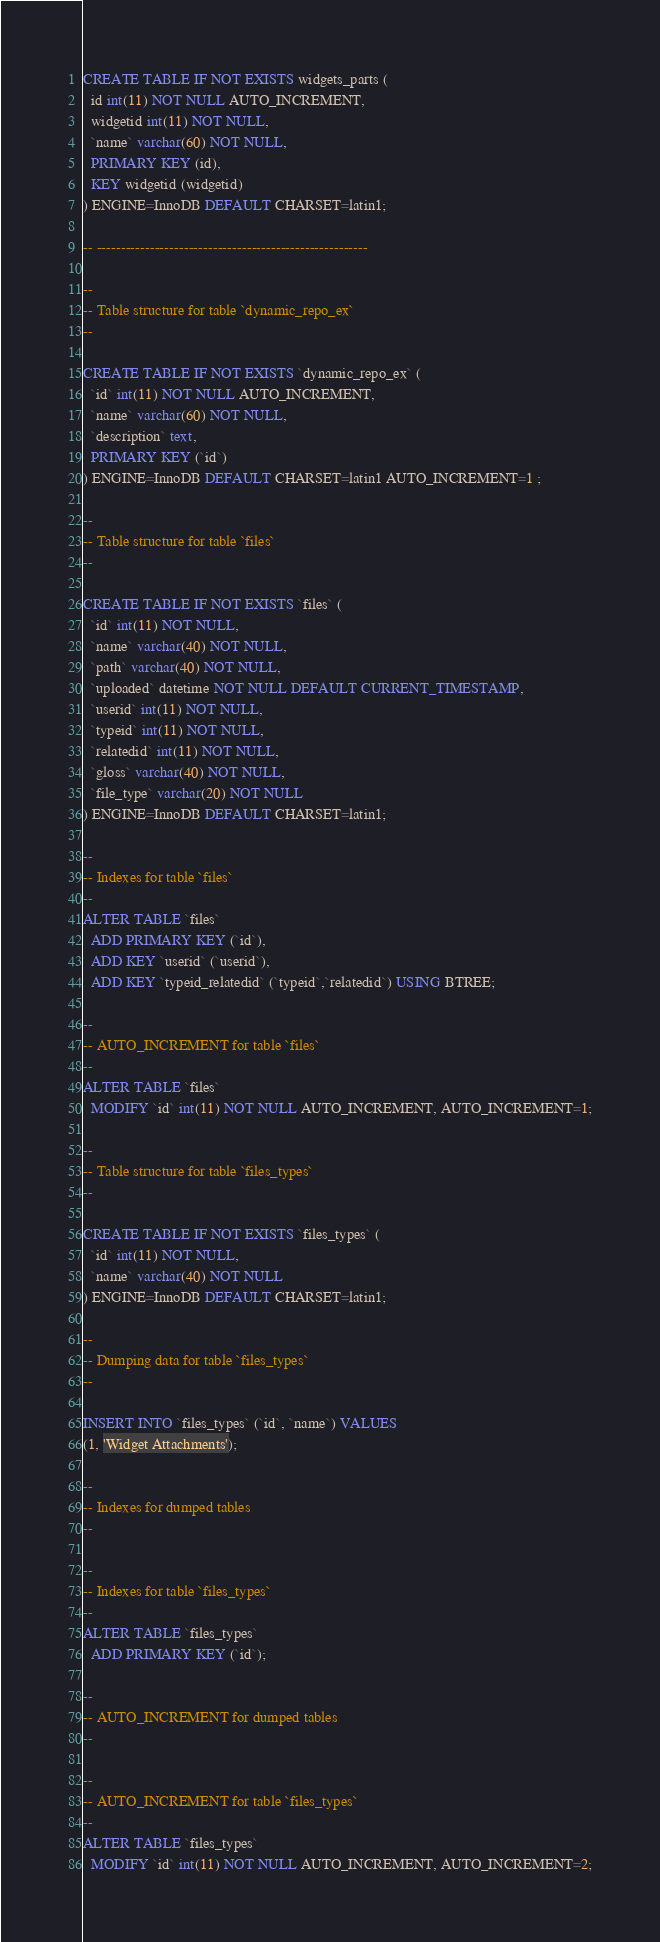Convert code to text. <code><loc_0><loc_0><loc_500><loc_500><_SQL_>
CREATE TABLE IF NOT EXISTS widgets_parts (
  id int(11) NOT NULL AUTO_INCREMENT,
  widgetid int(11) NOT NULL,
  `name` varchar(60) NOT NULL,
  PRIMARY KEY (id),
  KEY widgetid (widgetid)
) ENGINE=InnoDB DEFAULT CHARSET=latin1;

-- --------------------------------------------------------

--
-- Table structure for table `dynamic_repo_ex`
--

CREATE TABLE IF NOT EXISTS `dynamic_repo_ex` (
  `id` int(11) NOT NULL AUTO_INCREMENT,
  `name` varchar(60) NOT NULL,
  `description` text,
  PRIMARY KEY (`id`)
) ENGINE=InnoDB DEFAULT CHARSET=latin1 AUTO_INCREMENT=1 ;

--
-- Table structure for table `files`
--

CREATE TABLE IF NOT EXISTS `files` (
  `id` int(11) NOT NULL,
  `name` varchar(40) NOT NULL,
  `path` varchar(40) NOT NULL,
  `uploaded` datetime NOT NULL DEFAULT CURRENT_TIMESTAMP,
  `userid` int(11) NOT NULL,
  `typeid` int(11) NOT NULL,
  `relatedid` int(11) NOT NULL,
  `gloss` varchar(40) NOT NULL,
  `file_type` varchar(20) NOT NULL
) ENGINE=InnoDB DEFAULT CHARSET=latin1;

--
-- Indexes for table `files`
--
ALTER TABLE `files`
  ADD PRIMARY KEY (`id`),
  ADD KEY `userid` (`userid`),
  ADD KEY `typeid_relatedid` (`typeid`,`relatedid`) USING BTREE;

--
-- AUTO_INCREMENT for table `files`
--
ALTER TABLE `files`
  MODIFY `id` int(11) NOT NULL AUTO_INCREMENT, AUTO_INCREMENT=1;

--
-- Table structure for table `files_types`
--

CREATE TABLE IF NOT EXISTS `files_types` (
  `id` int(11) NOT NULL,
  `name` varchar(40) NOT NULL
) ENGINE=InnoDB DEFAULT CHARSET=latin1;

--
-- Dumping data for table `files_types`
--

INSERT INTO `files_types` (`id`, `name`) VALUES
(1, 'Widget Attachments');

--
-- Indexes for dumped tables
--

--
-- Indexes for table `files_types`
--
ALTER TABLE `files_types`
  ADD PRIMARY KEY (`id`);

--
-- AUTO_INCREMENT for dumped tables
--

--
-- AUTO_INCREMENT for table `files_types`
--
ALTER TABLE `files_types`
  MODIFY `id` int(11) NOT NULL AUTO_INCREMENT, AUTO_INCREMENT=2;
</code> 